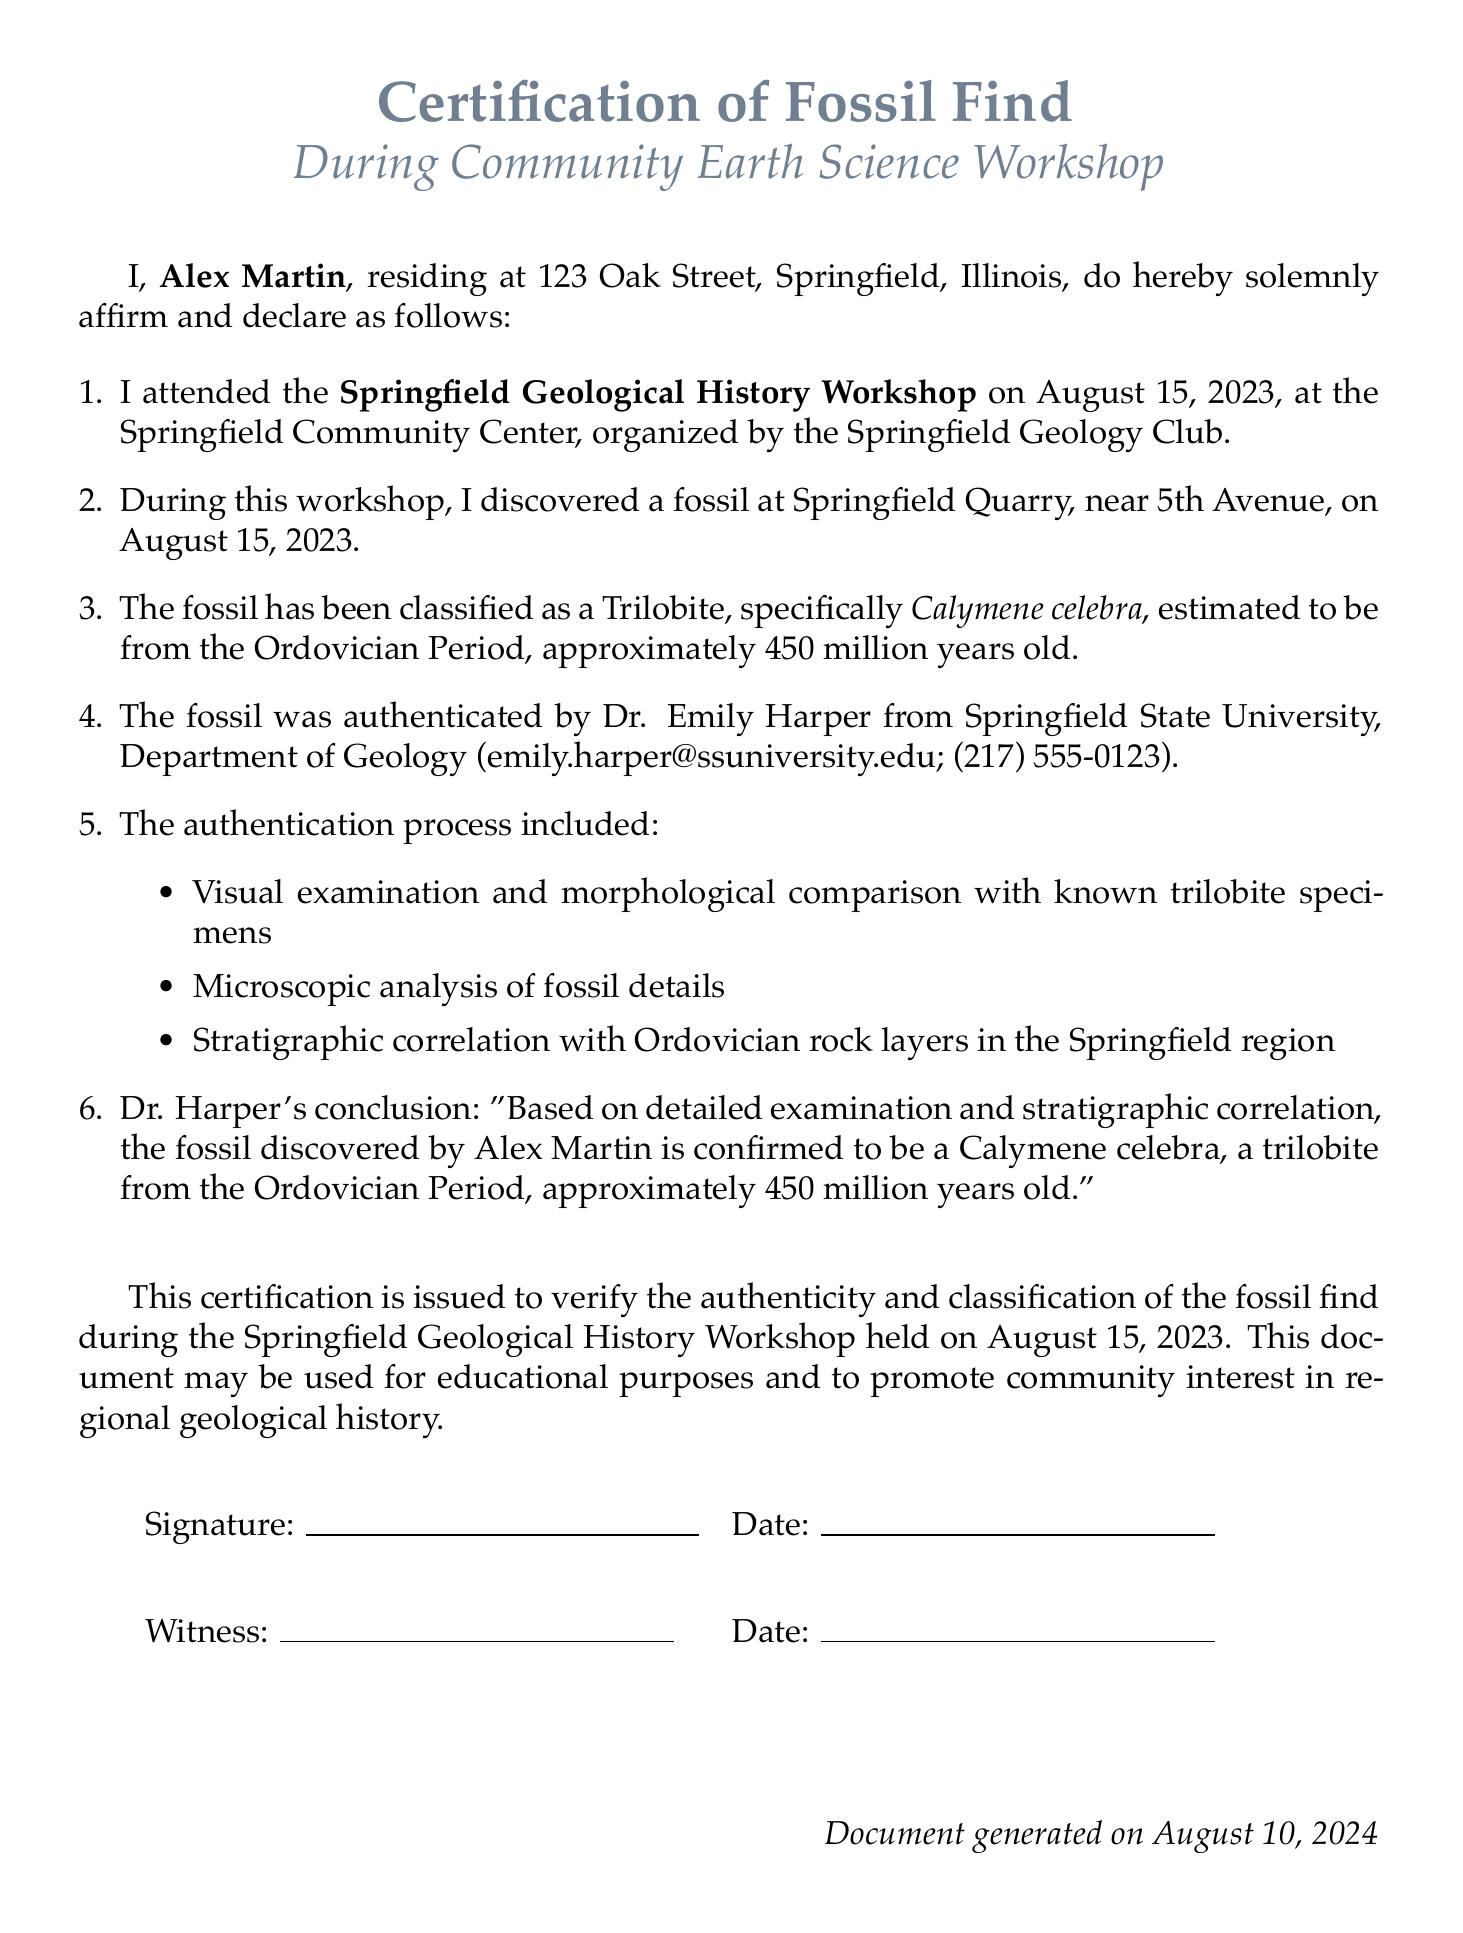What is the name of the person who discovered the fossil? The name of the person who discovered the fossil is stated in the document as Alex Martin.
Answer: Alex Martin When did the Springfield Geological History Workshop take place? The workshop date is mentioned in the document as August 15, 2023.
Answer: August 15, 2023 What type of fossil was discovered? The document specifically classifies the fossil as a Trilobite.
Answer: Trilobite Who authenticated the fossil? The document indicates that Dr. Emily Harper authenticated the fossil.
Answer: Dr. Emily Harper What is the estimated age of the fossil? The document provides the estimation of the fossil's age as approximately 450 million years old.
Answer: 450 million years Which university is Dr. Emily Harper affiliated with? The document states that Dr. Emily Harper is from Springfield State University.
Answer: Springfield State University What process was included in the authentication of the fossil? The document lists several methods, including visual examination, microscopic analysis, and stratigraphic correlation.
Answer: Visual examination and morphological comparison with known trilobite specimens For what purpose may this certification be used? The document mentions that the certification may be used for educational purposes and to promote community interest in geological history.
Answer: Educational purposes What was the location where the fossil was found? The document specifies that the fossil was found at Springfield Quarry, near 5th Avenue.
Answer: Springfield Quarry, near 5th Avenue 